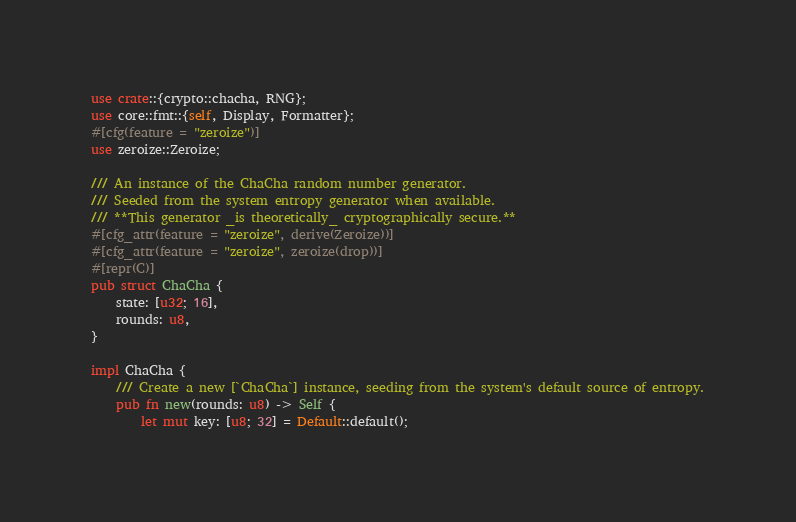<code> <loc_0><loc_0><loc_500><loc_500><_Rust_>use crate::{crypto::chacha, RNG};
use core::fmt::{self, Display, Formatter};
#[cfg(feature = "zeroize")]
use zeroize::Zeroize;

/// An instance of the ChaCha random number generator.
/// Seeded from the system entropy generator when available.
/// **This generator _is theoretically_ cryptographically secure.**
#[cfg_attr(feature = "zeroize", derive(Zeroize))]
#[cfg_attr(feature = "zeroize", zeroize(drop))]
#[repr(C)]
pub struct ChaCha {
	state: [u32; 16],
	rounds: u8,
}

impl ChaCha {
	/// Create a new [`ChaCha`] instance, seeding from the system's default source of entropy.
	pub fn new(rounds: u8) -> Self {
		let mut key: [u8; 32] = Default::default();</code> 